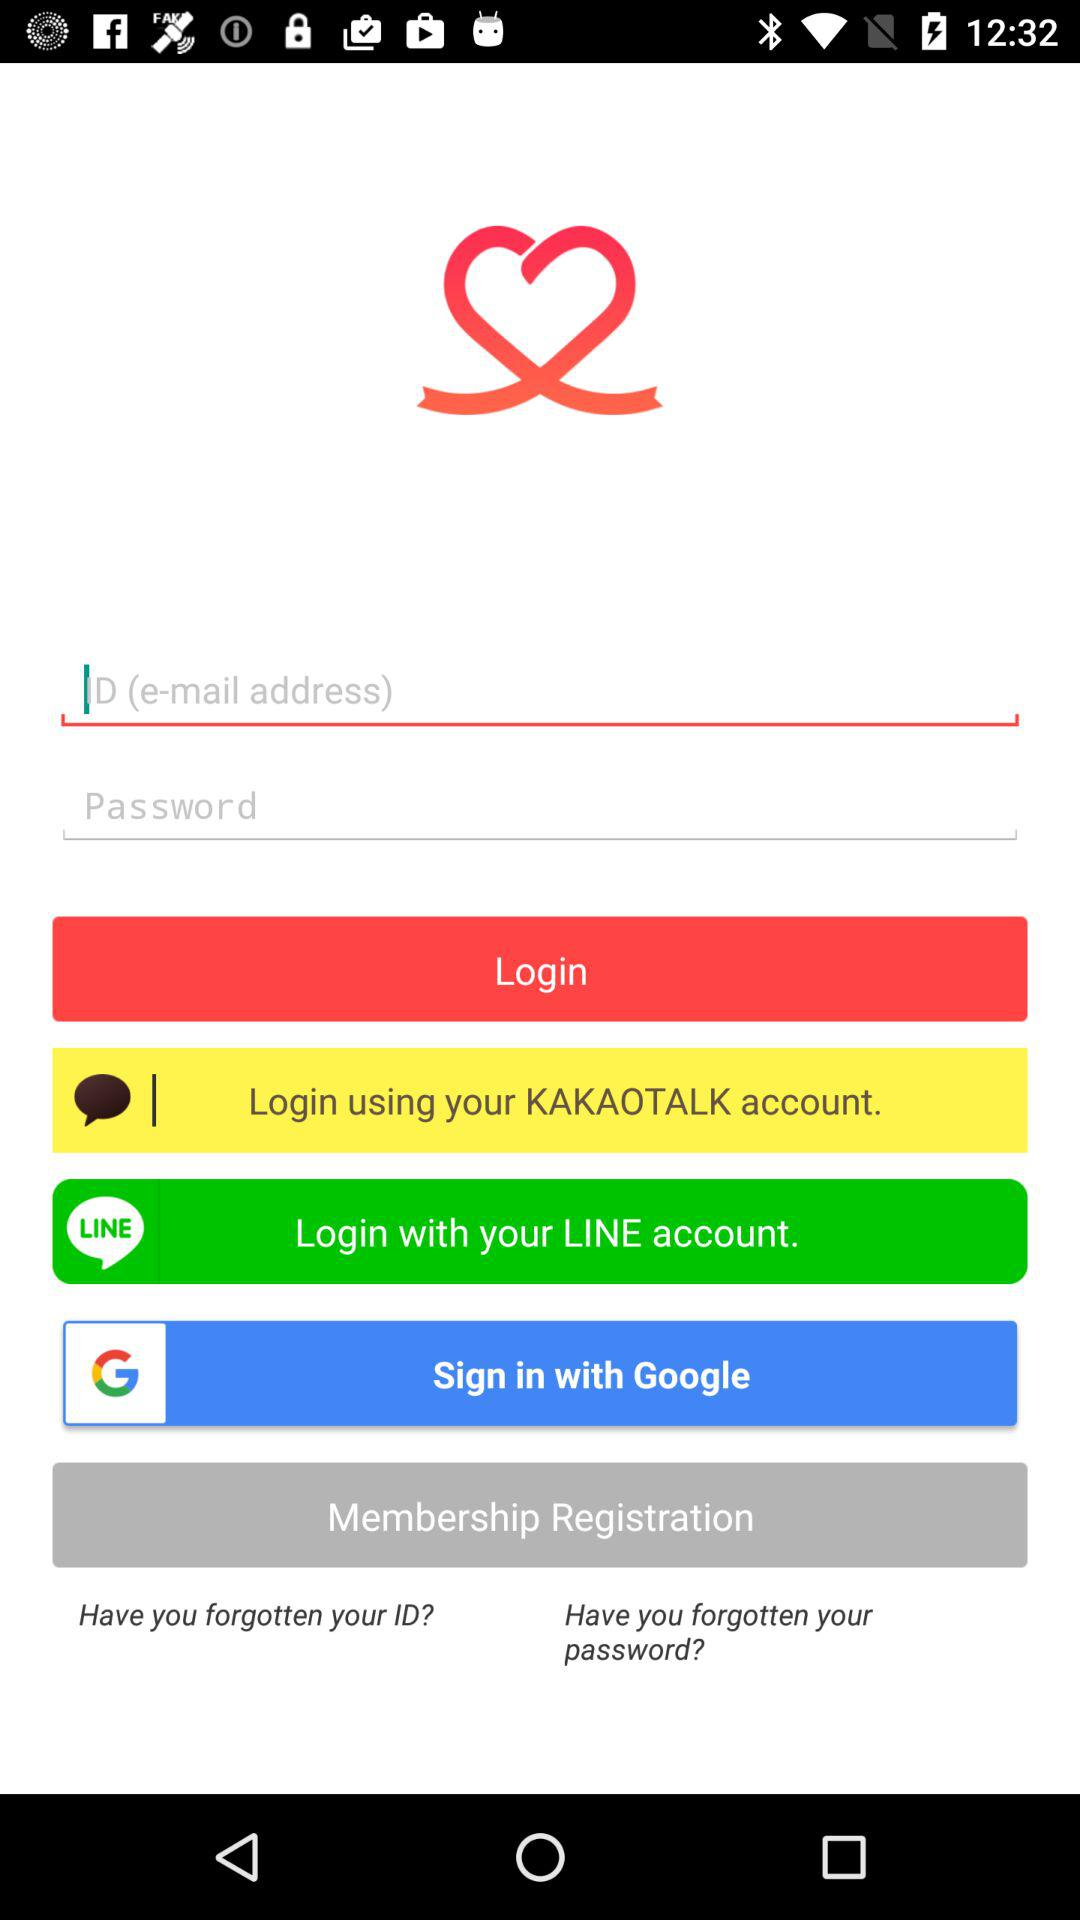How many input fields are there for login?
Answer the question using a single word or phrase. 2 